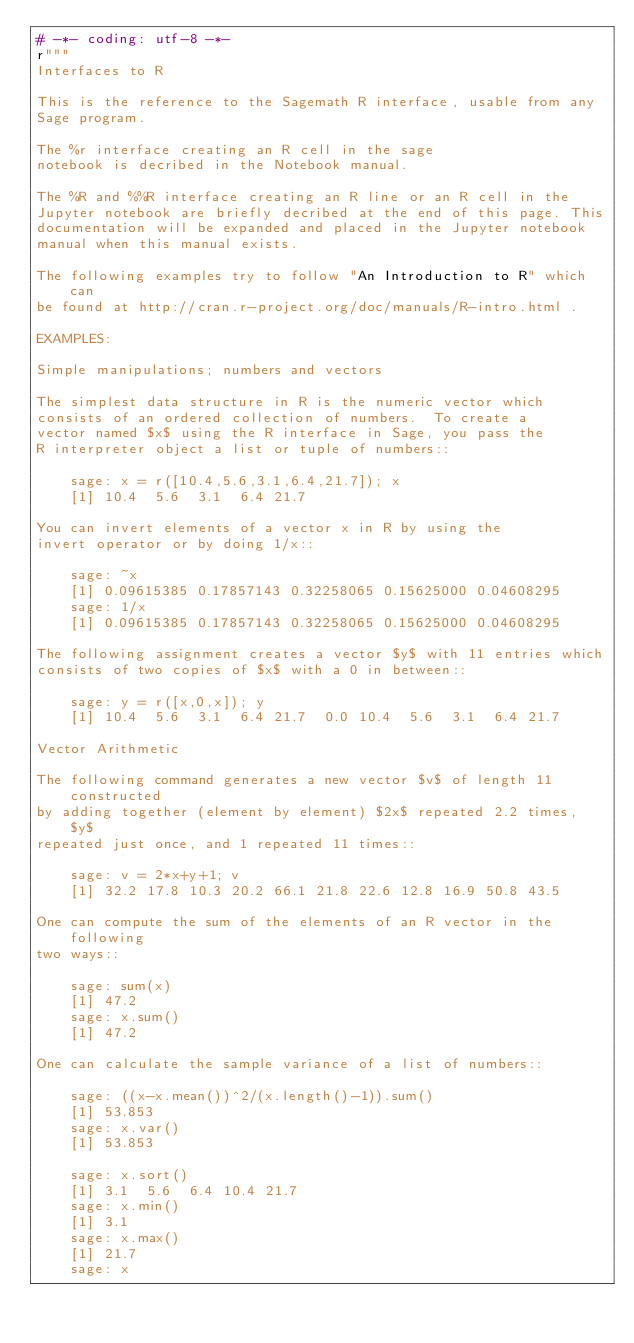Convert code to text. <code><loc_0><loc_0><loc_500><loc_500><_Python_># -*- coding: utf-8 -*-
r"""
Interfaces to R

This is the reference to the Sagemath R interface, usable from any
Sage program.

The %r interface creating an R cell in the sage
notebook is decribed in the Notebook manual.

The %R and %%R interface creating an R line or an R cell in the
Jupyter notebook are briefly decribed at the end of this page. This
documentation will be expanded and placed in the Jupyter notebook
manual when this manual exists.  

The following examples try to follow "An Introduction to R" which can
be found at http://cran.r-project.org/doc/manuals/R-intro.html .

EXAMPLES:

Simple manipulations; numbers and vectors

The simplest data structure in R is the numeric vector which
consists of an ordered collection of numbers.  To create a
vector named $x$ using the R interface in Sage, you pass the
R interpreter object a list or tuple of numbers::

    sage: x = r([10.4,5.6,3.1,6.4,21.7]); x
    [1] 10.4  5.6  3.1  6.4 21.7

You can invert elements of a vector x in R by using the
invert operator or by doing 1/x::

    sage: ~x
    [1] 0.09615385 0.17857143 0.32258065 0.15625000 0.04608295
    sage: 1/x
    [1] 0.09615385 0.17857143 0.32258065 0.15625000 0.04608295

The following assignment creates a vector $y$ with 11 entries which
consists of two copies of $x$ with a 0 in between::

    sage: y = r([x,0,x]); y
    [1] 10.4  5.6  3.1  6.4 21.7  0.0 10.4  5.6  3.1  6.4 21.7

Vector Arithmetic

The following command generates a new vector $v$ of length 11 constructed
by adding together (element by element) $2x$ repeated 2.2 times, $y$
repeated just once, and 1 repeated 11 times::

    sage: v = 2*x+y+1; v
    [1] 32.2 17.8 10.3 20.2 66.1 21.8 22.6 12.8 16.9 50.8 43.5

One can compute the sum of the elements of an R vector in the following
two ways::

    sage: sum(x)
    [1] 47.2
    sage: x.sum()
    [1] 47.2

One can calculate the sample variance of a list of numbers::

    sage: ((x-x.mean())^2/(x.length()-1)).sum()
    [1] 53.853
    sage: x.var()
    [1] 53.853

    sage: x.sort()
    [1] 3.1  5.6  6.4 10.4 21.7
    sage: x.min()
    [1] 3.1
    sage: x.max()
    [1] 21.7
    sage: x</code> 